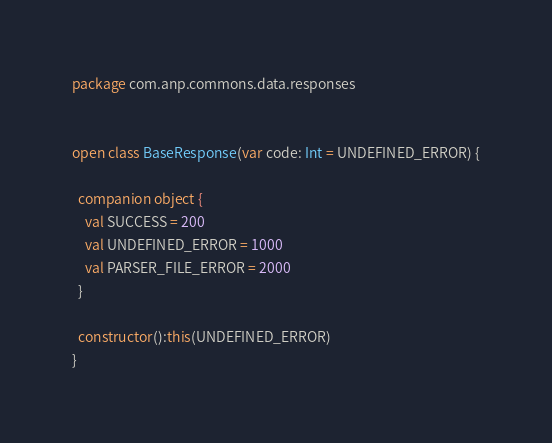Convert code to text. <code><loc_0><loc_0><loc_500><loc_500><_Kotlin_>package com.anp.commons.data.responses


open class BaseResponse(var code: Int = UNDEFINED_ERROR) {

  companion object {
    val SUCCESS = 200
    val UNDEFINED_ERROR = 1000
    val PARSER_FILE_ERROR = 2000
  }

  constructor():this(UNDEFINED_ERROR)
}</code> 